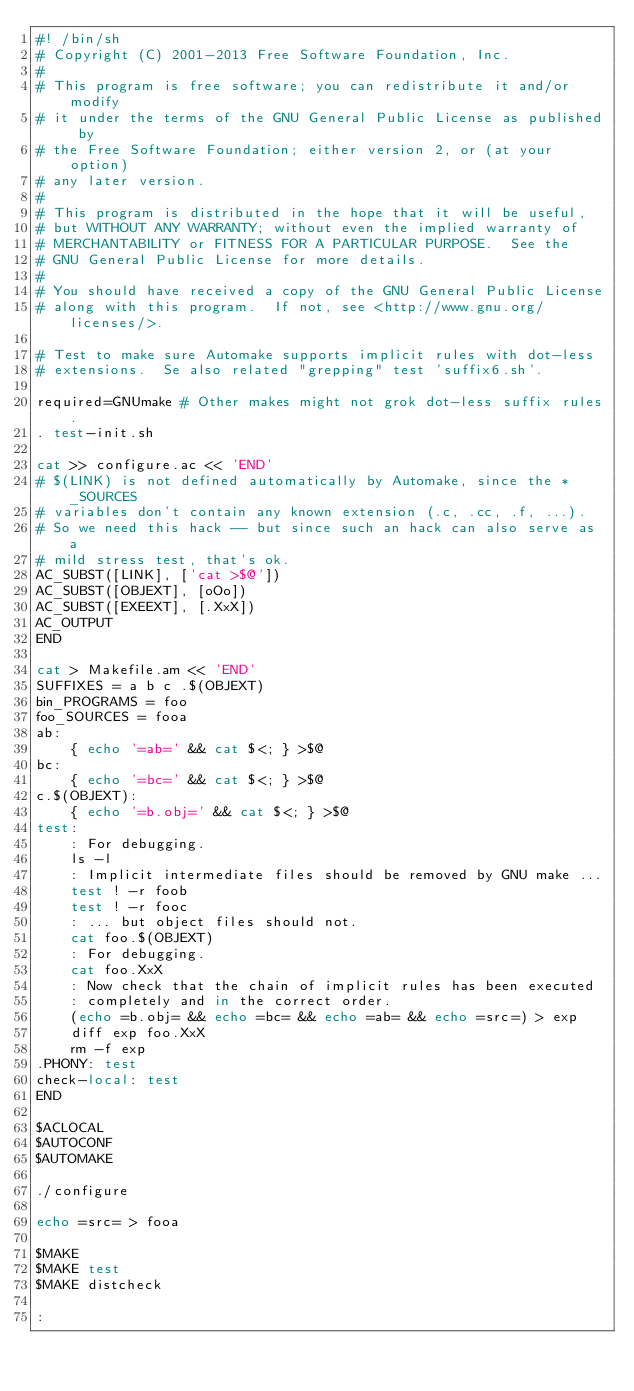Convert code to text. <code><loc_0><loc_0><loc_500><loc_500><_Bash_>#! /bin/sh
# Copyright (C) 2001-2013 Free Software Foundation, Inc.
#
# This program is free software; you can redistribute it and/or modify
# it under the terms of the GNU General Public License as published by
# the Free Software Foundation; either version 2, or (at your option)
# any later version.
#
# This program is distributed in the hope that it will be useful,
# but WITHOUT ANY WARRANTY; without even the implied warranty of
# MERCHANTABILITY or FITNESS FOR A PARTICULAR PURPOSE.  See the
# GNU General Public License for more details.
#
# You should have received a copy of the GNU General Public License
# along with this program.  If not, see <http://www.gnu.org/licenses/>.

# Test to make sure Automake supports implicit rules with dot-less
# extensions.  Se also related "grepping" test 'suffix6.sh'.

required=GNUmake # Other makes might not grok dot-less suffix rules.
. test-init.sh

cat >> configure.ac << 'END'
# $(LINK) is not defined automatically by Automake, since the *_SOURCES
# variables don't contain any known extension (.c, .cc, .f, ...).
# So we need this hack -- but since such an hack can also serve as a
# mild stress test, that's ok.
AC_SUBST([LINK], ['cat >$@'])
AC_SUBST([OBJEXT], [oOo])
AC_SUBST([EXEEXT], [.XxX])
AC_OUTPUT
END

cat > Makefile.am << 'END'
SUFFIXES = a b c .$(OBJEXT)
bin_PROGRAMS = foo
foo_SOURCES = fooa
ab:
	{ echo '=ab=' && cat $<; } >$@
bc:
	{ echo '=bc=' && cat $<; } >$@
c.$(OBJEXT):
	{ echo '=b.obj=' && cat $<; } >$@
test:
	: For debugging.
	ls -l
	: Implicit intermediate files should be removed by GNU make ...
	test ! -r foob
	test ! -r fooc
	: ... but object files should not.
	cat foo.$(OBJEXT)
	: For debugging.
	cat foo.XxX
	: Now check that the chain of implicit rules has been executed
	: completely and in the correct order.
	(echo =b.obj= && echo =bc= && echo =ab= && echo =src=) > exp
	diff exp foo.XxX
	rm -f exp
.PHONY: test
check-local: test
END

$ACLOCAL
$AUTOCONF
$AUTOMAKE

./configure

echo =src= > fooa

$MAKE
$MAKE test
$MAKE distcheck

:
</code> 